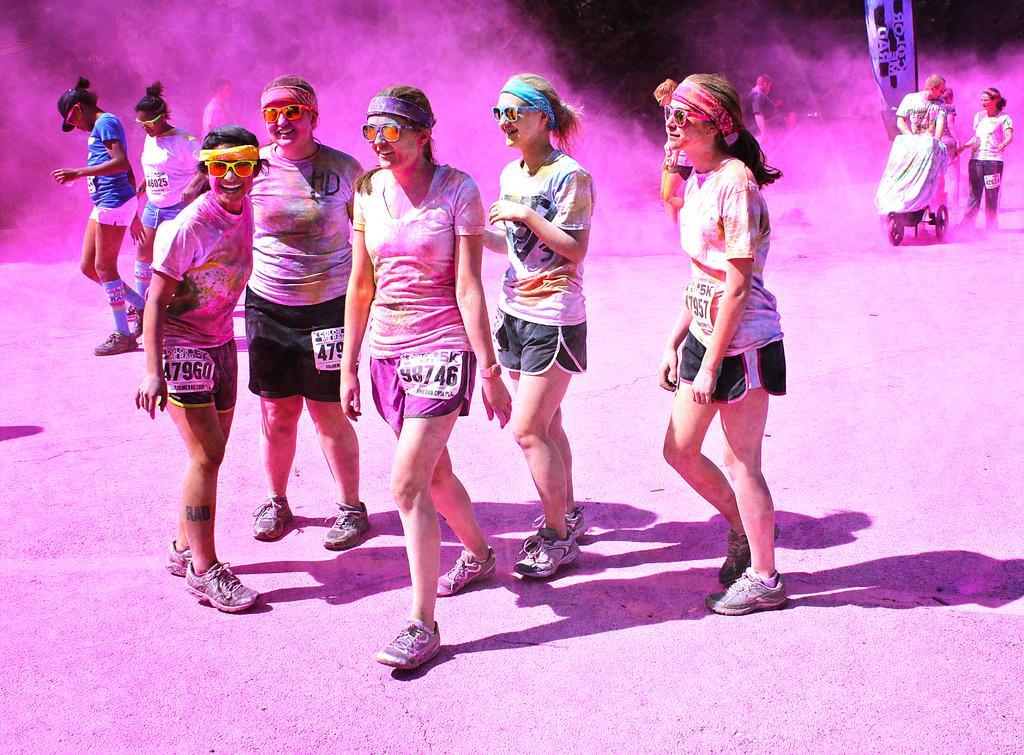Please provide a concise description of this image. In this image we can see there are persons standing on the ground. And there is an object covered with cloth. 